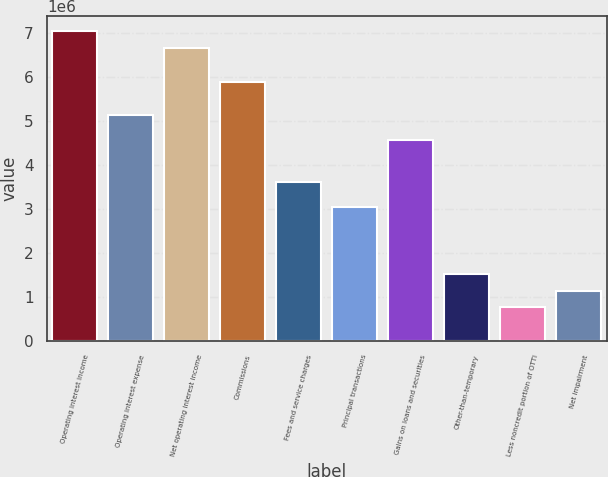Convert chart to OTSL. <chart><loc_0><loc_0><loc_500><loc_500><bar_chart><fcel>Operating interest income<fcel>Operating interest expense<fcel>Net operating interest income<fcel>Commissions<fcel>Fees and service charges<fcel>Principal transactions<fcel>Gains on loans and securities<fcel>Other-than-temporary<fcel>Less noncredit portion of OTTI<fcel>Net impairment<nl><fcel>7.02813e+06<fcel>5.12864e+06<fcel>6.64823e+06<fcel>5.88844e+06<fcel>3.60904e+06<fcel>3.03919e+06<fcel>4.55879e+06<fcel>1.5196e+06<fcel>759799<fcel>1.1397e+06<nl></chart> 